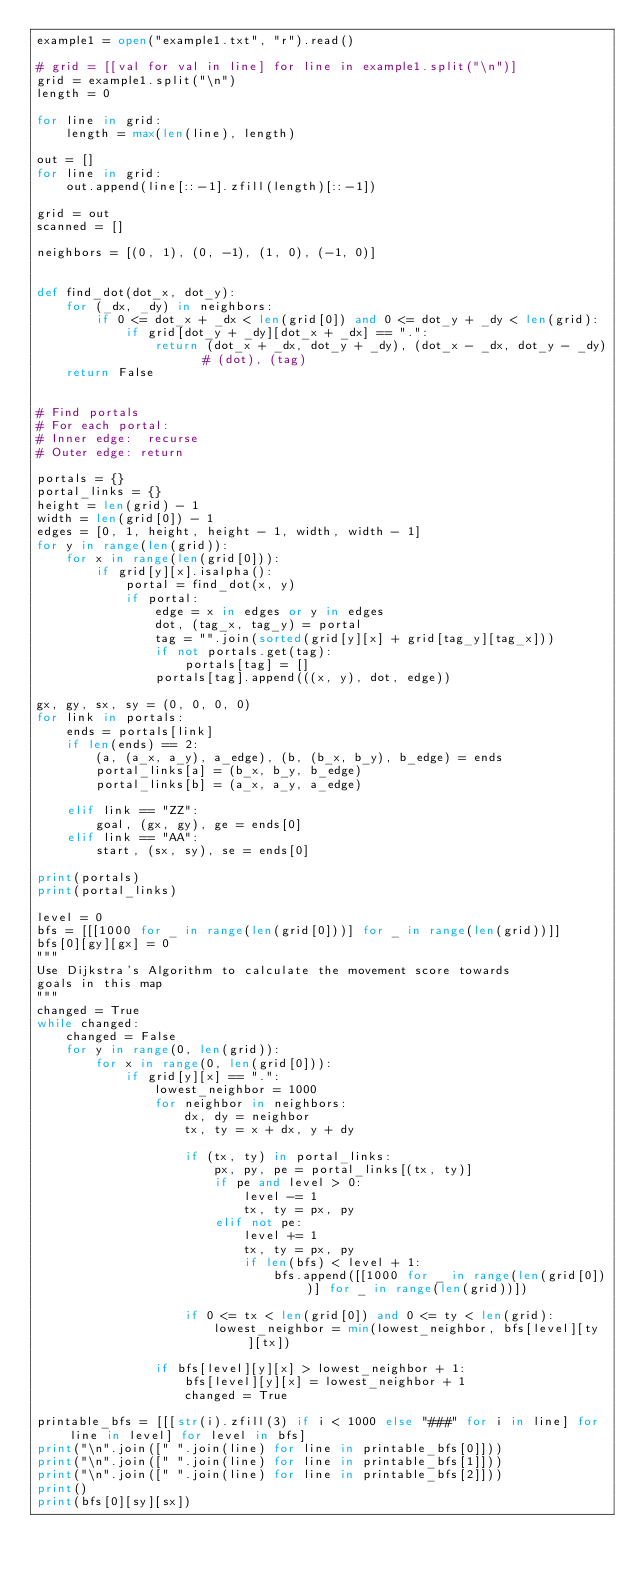Convert code to text. <code><loc_0><loc_0><loc_500><loc_500><_Python_>example1 = open("example1.txt", "r").read()

# grid = [[val for val in line] for line in example1.split("\n")]
grid = example1.split("\n")
length = 0

for line in grid:
    length = max(len(line), length)

out = []
for line in grid:
    out.append(line[::-1].zfill(length)[::-1])

grid = out
scanned = []

neighbors = [(0, 1), (0, -1), (1, 0), (-1, 0)]


def find_dot(dot_x, dot_y):
    for (_dx, _dy) in neighbors:
        if 0 <= dot_x + _dx < len(grid[0]) and 0 <= dot_y + _dy < len(grid):
            if grid[dot_y + _dy][dot_x + _dx] == ".":
                return (dot_x + _dx, dot_y + _dy), (dot_x - _dx, dot_y - _dy)  # (dot), (tag)
    return False


# Find portals
# For each portal:
# Inner edge:  recurse
# Outer edge: return

portals = {}
portal_links = {}
height = len(grid) - 1
width = len(grid[0]) - 1
edges = [0, 1, height, height - 1, width, width - 1]
for y in range(len(grid)):
    for x in range(len(grid[0])):
        if grid[y][x].isalpha():
            portal = find_dot(x, y)
            if portal:
                edge = x in edges or y in edges
                dot, (tag_x, tag_y) = portal
                tag = "".join(sorted(grid[y][x] + grid[tag_y][tag_x]))
                if not portals.get(tag):
                    portals[tag] = []
                portals[tag].append(((x, y), dot, edge))

gx, gy, sx, sy = (0, 0, 0, 0)
for link in portals:
    ends = portals[link]
    if len(ends) == 2:
        (a, (a_x, a_y), a_edge), (b, (b_x, b_y), b_edge) = ends
        portal_links[a] = (b_x, b_y, b_edge)
        portal_links[b] = (a_x, a_y, a_edge)

    elif link == "ZZ":
        goal, (gx, gy), ge = ends[0]
    elif link == "AA":
        start, (sx, sy), se = ends[0]

print(portals)
print(portal_links)

level = 0
bfs = [[[1000 for _ in range(len(grid[0]))] for _ in range(len(grid))]]
bfs[0][gy][gx] = 0
"""
Use Dijkstra's Algorithm to calculate the movement score towards
goals in this map
"""
changed = True
while changed:
    changed = False
    for y in range(0, len(grid)):
        for x in range(0, len(grid[0])):
            if grid[y][x] == ".":
                lowest_neighbor = 1000
                for neighbor in neighbors:
                    dx, dy = neighbor
                    tx, ty = x + dx, y + dy

                    if (tx, ty) in portal_links:
                        px, py, pe = portal_links[(tx, ty)]
                        if pe and level > 0:
                            level -= 1
                            tx, ty = px, py
                        elif not pe:
                            level += 1
                            tx, ty = px, py
                            if len(bfs) < level + 1:
                                bfs.append([[1000 for _ in range(len(grid[0]))] for _ in range(len(grid))])

                    if 0 <= tx < len(grid[0]) and 0 <= ty < len(grid):
                        lowest_neighbor = min(lowest_neighbor, bfs[level][ty][tx])

                if bfs[level][y][x] > lowest_neighbor + 1:
                    bfs[level][y][x] = lowest_neighbor + 1
                    changed = True

printable_bfs = [[[str(i).zfill(3) if i < 1000 else "###" for i in line] for line in level] for level in bfs]
print("\n".join([" ".join(line) for line in printable_bfs[0]]))
print("\n".join([" ".join(line) for line in printable_bfs[1]]))
print("\n".join([" ".join(line) for line in printable_bfs[2]]))
print()
print(bfs[0][sy][sx])
</code> 